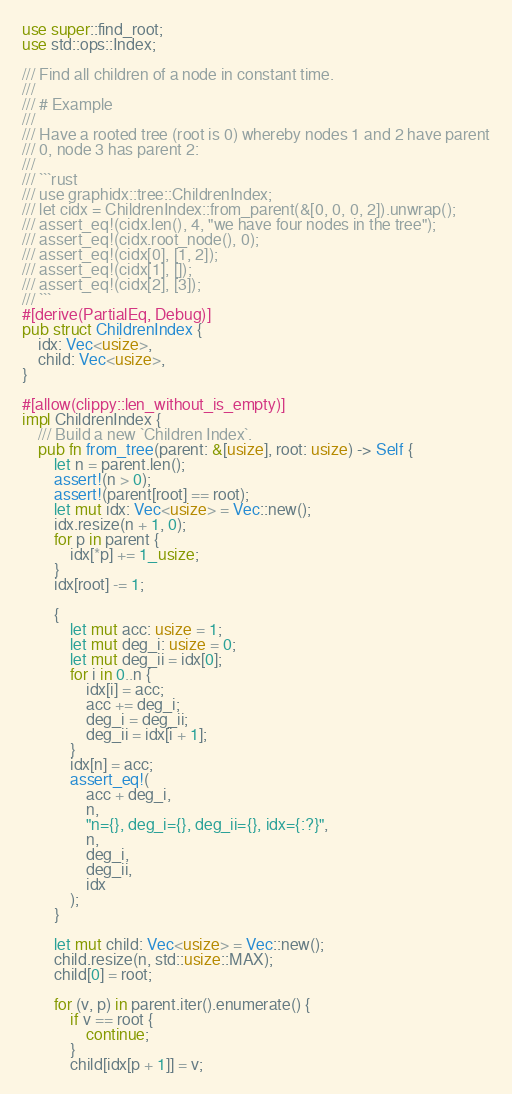<code> <loc_0><loc_0><loc_500><loc_500><_Rust_>use super::find_root;
use std::ops::Index;

/// Find all children of a node in constant time.
///
/// # Example
///
/// Have a rooted tree (root is 0) whereby nodes 1 and 2 have parent
/// 0, node 3 has parent 2:
///
/// ```rust
/// use graphidx::tree::ChildrenIndex;
/// let cidx = ChildrenIndex::from_parent(&[0, 0, 0, 2]).unwrap();
/// assert_eq!(cidx.len(), 4, "we have four nodes in the tree");
/// assert_eq!(cidx.root_node(), 0);
/// assert_eq!(cidx[0], [1, 2]);
/// assert_eq!(cidx[1], []);
/// assert_eq!(cidx[2], [3]);
/// ```
#[derive(PartialEq, Debug)]
pub struct ChildrenIndex {
    idx: Vec<usize>,
    child: Vec<usize>,
}

#[allow(clippy::len_without_is_empty)]
impl ChildrenIndex {
    /// Build a new `Children Index`.
    pub fn from_tree(parent: &[usize], root: usize) -> Self {
        let n = parent.len();
        assert!(n > 0);
        assert!(parent[root] == root);
        let mut idx: Vec<usize> = Vec::new();
        idx.resize(n + 1, 0);
        for p in parent {
            idx[*p] += 1_usize;
        }
        idx[root] -= 1;

        {
            let mut acc: usize = 1;
            let mut deg_i: usize = 0;
            let mut deg_ii = idx[0];
            for i in 0..n {
                idx[i] = acc;
                acc += deg_i;
                deg_i = deg_ii;
                deg_ii = idx[i + 1];
            }
            idx[n] = acc;
            assert_eq!(
                acc + deg_i,
                n,
                "n={}, deg_i={}, deg_ii={}, idx={:?}",
                n,
                deg_i,
                deg_ii,
                idx
            );
        }

        let mut child: Vec<usize> = Vec::new();
        child.resize(n, std::usize::MAX);
        child[0] = root;

        for (v, p) in parent.iter().enumerate() {
            if v == root {
                continue;
            }
            child[idx[p + 1]] = v;</code> 